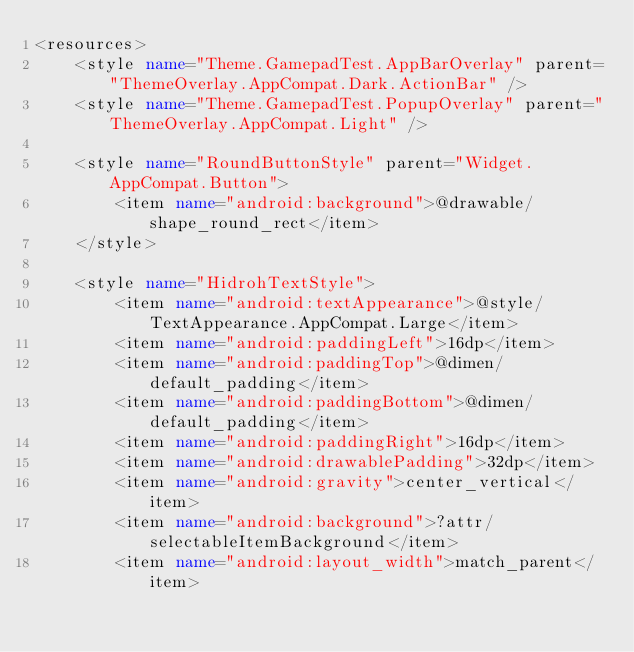Convert code to text. <code><loc_0><loc_0><loc_500><loc_500><_XML_><resources>
    <style name="Theme.GamepadTest.AppBarOverlay" parent="ThemeOverlay.AppCompat.Dark.ActionBar" />
    <style name="Theme.GamepadTest.PopupOverlay" parent="ThemeOverlay.AppCompat.Light" />

    <style name="RoundButtonStyle" parent="Widget.AppCompat.Button">
        <item name="android:background">@drawable/shape_round_rect</item>
    </style>

    <style name="HidrohTextStyle">
        <item name="android:textAppearance">@style/TextAppearance.AppCompat.Large</item>
        <item name="android:paddingLeft">16dp</item>
        <item name="android:paddingTop">@dimen/default_padding</item>
        <item name="android:paddingBottom">@dimen/default_padding</item>
        <item name="android:paddingRight">16dp</item>
        <item name="android:drawablePadding">32dp</item>
        <item name="android:gravity">center_vertical</item>
        <item name="android:background">?attr/selectableItemBackground</item>
        <item name="android:layout_width">match_parent</item></code> 